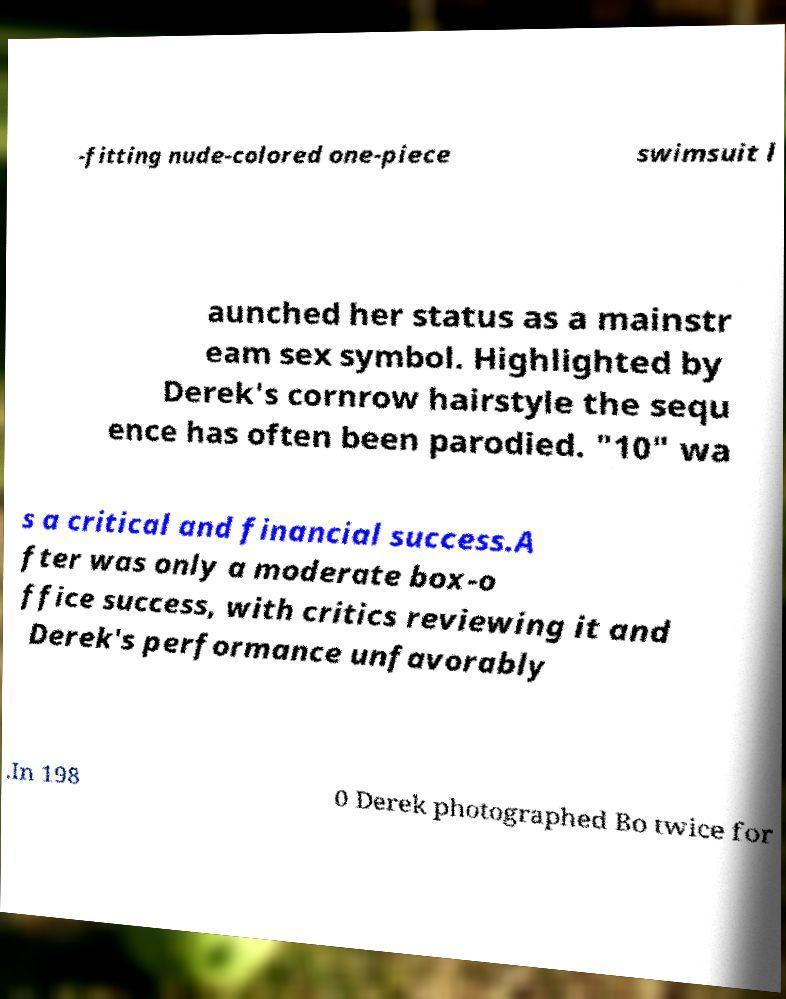Can you read and provide the text displayed in the image?This photo seems to have some interesting text. Can you extract and type it out for me? -fitting nude-colored one-piece swimsuit l aunched her status as a mainstr eam sex symbol. Highlighted by Derek's cornrow hairstyle the sequ ence has often been parodied. "10" wa s a critical and financial success.A fter was only a moderate box-o ffice success, with critics reviewing it and Derek's performance unfavorably .In 198 0 Derek photographed Bo twice for 